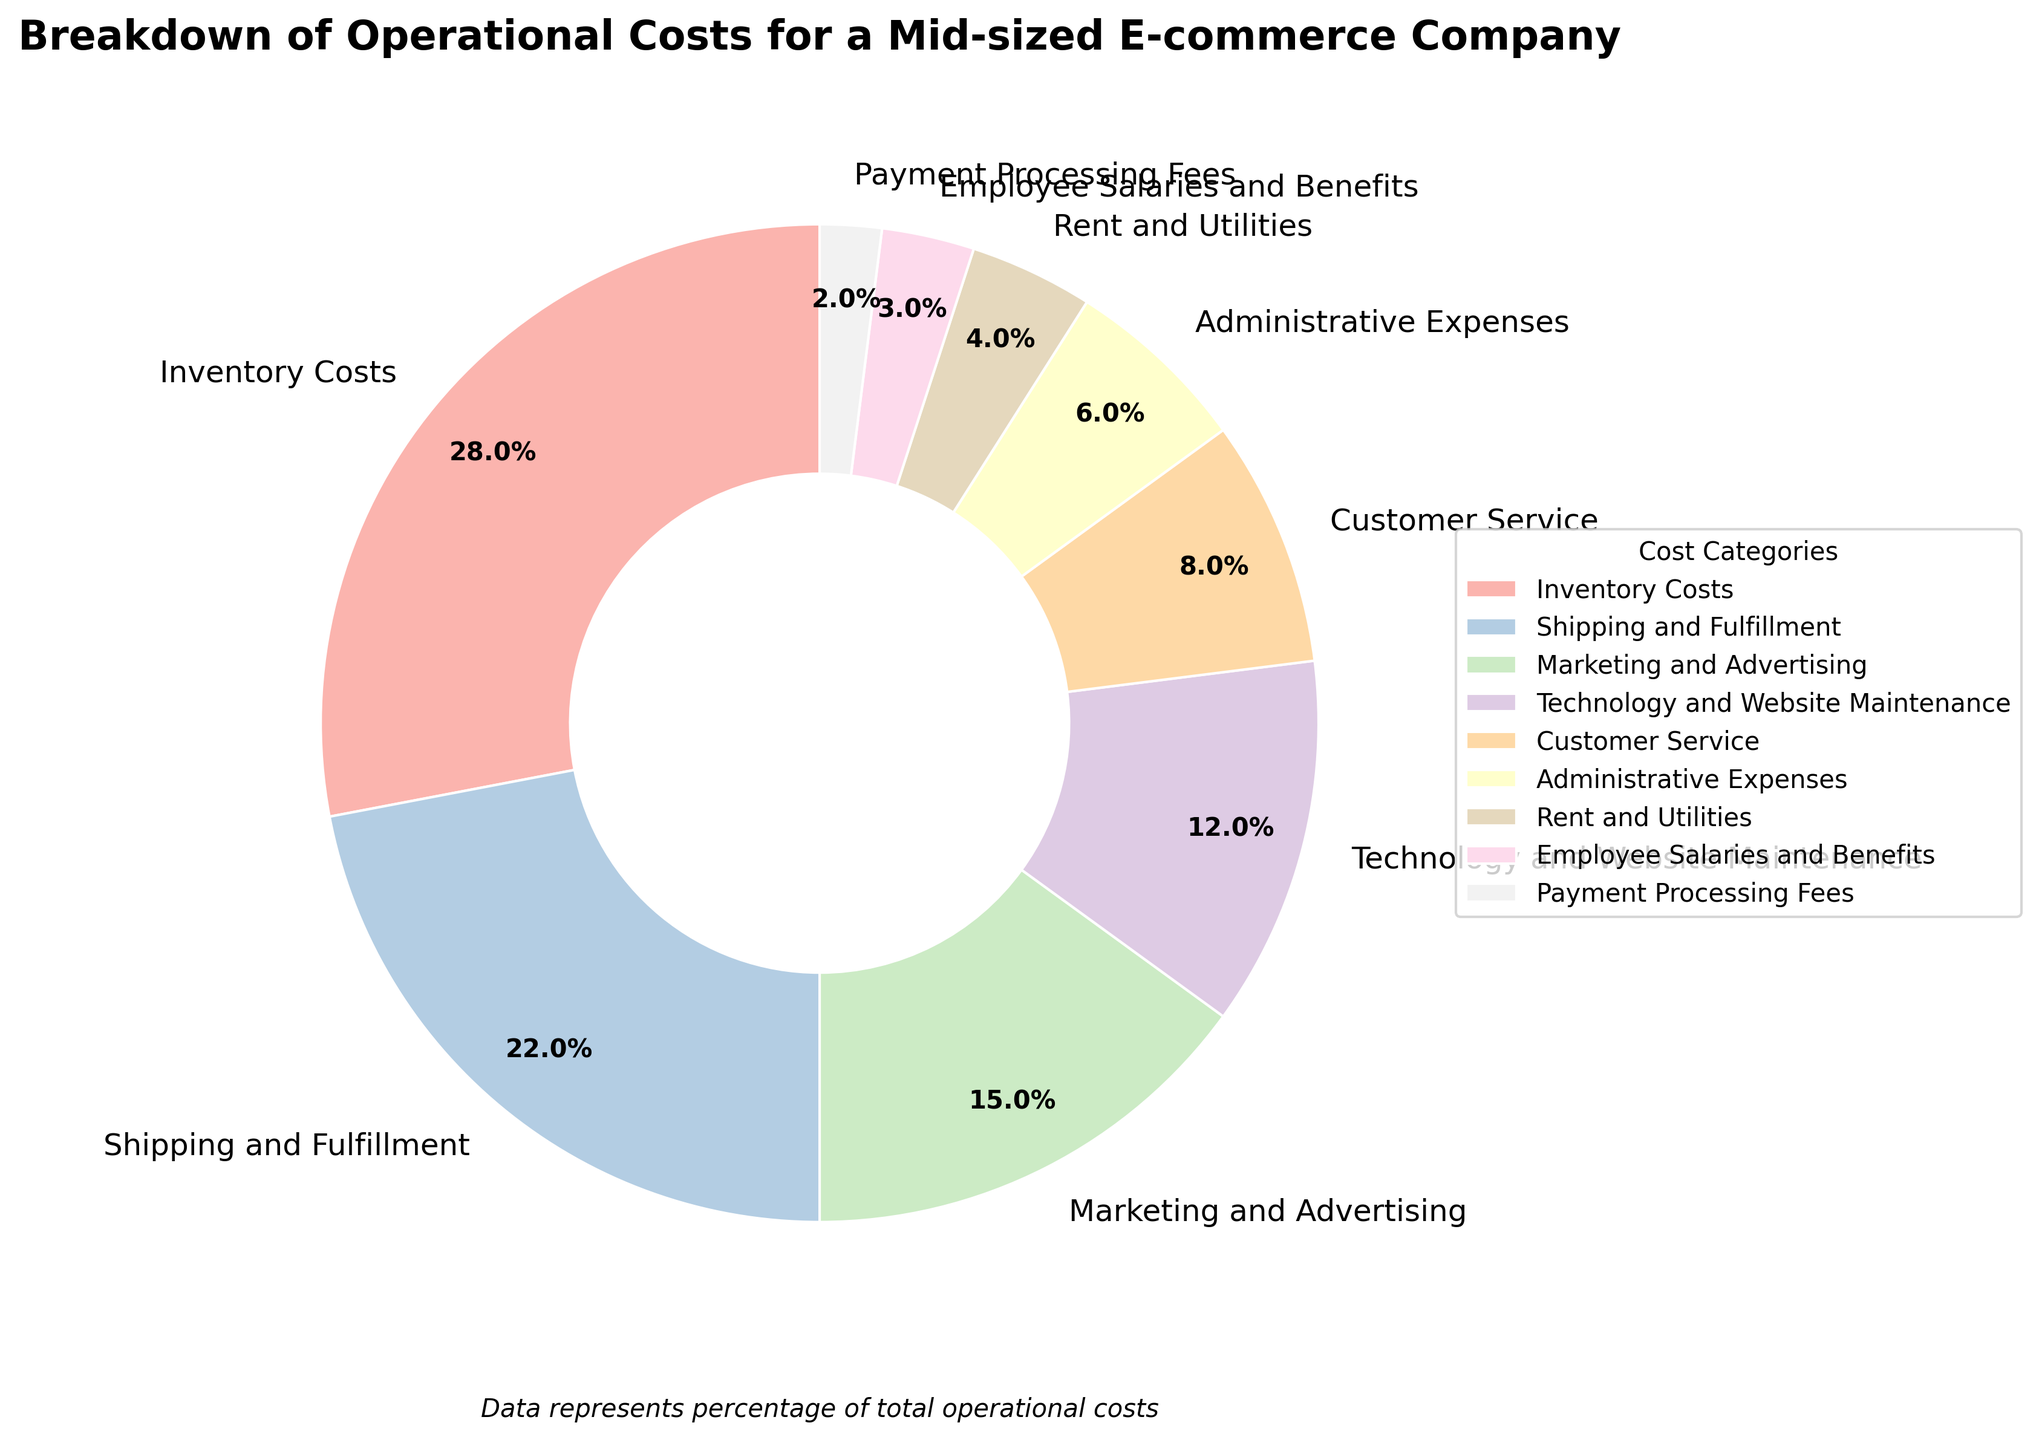What's the combined percentage of Inventory Costs and Shipping and Fulfillment? Inventory Costs contribute 28% and Shipping and Fulfillment contribute 22%. Adding these together, 28% + 22% = 50%.
Answer: 50% Which category has the smallest percentage of operational costs? By looking at the wedges in the pie chart, the smallest slice corresponds to Payment Processing Fees, which is 2%.
Answer: Payment Processing Fees Which is greater, Marketing and Advertising, or Technology and Website Maintenance? The pie chart shows Marketing and Advertising at 15% and Technology and Website Maintenance at 12%, so Marketing and Advertising is greater.
Answer: Marketing and Advertising What is the difference in percentage between Employee Salaries and Benefits and Rent and Utilities? Employee Salaries and Benefits contribute 3% and Rent and Utilities contribute 4%. Subtracting the smaller from the larger, 4% - 3% = 1%.
Answer: 1% What's the sum percentage of Administrative Expenses, Rent and Utilities, and Payment Processing Fees? Administrative Expenses contribute 6%, Rent and Utilities contribute 4%, and Payment Processing Fees contribute 2%. Summing these percentages, 6% + 4% + 2% = 12%.
Answer: 12% Which category has the third-largest percentage of operational costs? The third-largest wedge is for Marketing and Advertising, which corresponds to 15%.
Answer: Marketing and Advertising Are Employee Salaries and Benefits more than Customer Service? Employee Salaries and Benefits are 3% while Customer Service is 8%, so Employee Salaries and Benefits are less than Customer Service.
Answer: No What's the ratio of Technology and Website Maintenance to Customer Service costs? Technology and Website Maintenance is 12% and Customer Service is 8%. The ratio is 12 / 8 = 1.5:1.
Answer: 1.5:1 How much greater are Inventory Costs compared to Administrative Expenses? Inventory Costs are 28% and Administrative Expenses are 6%. Subtracting the smaller from the larger, 28% - 6% = 22%.
Answer: 22% 